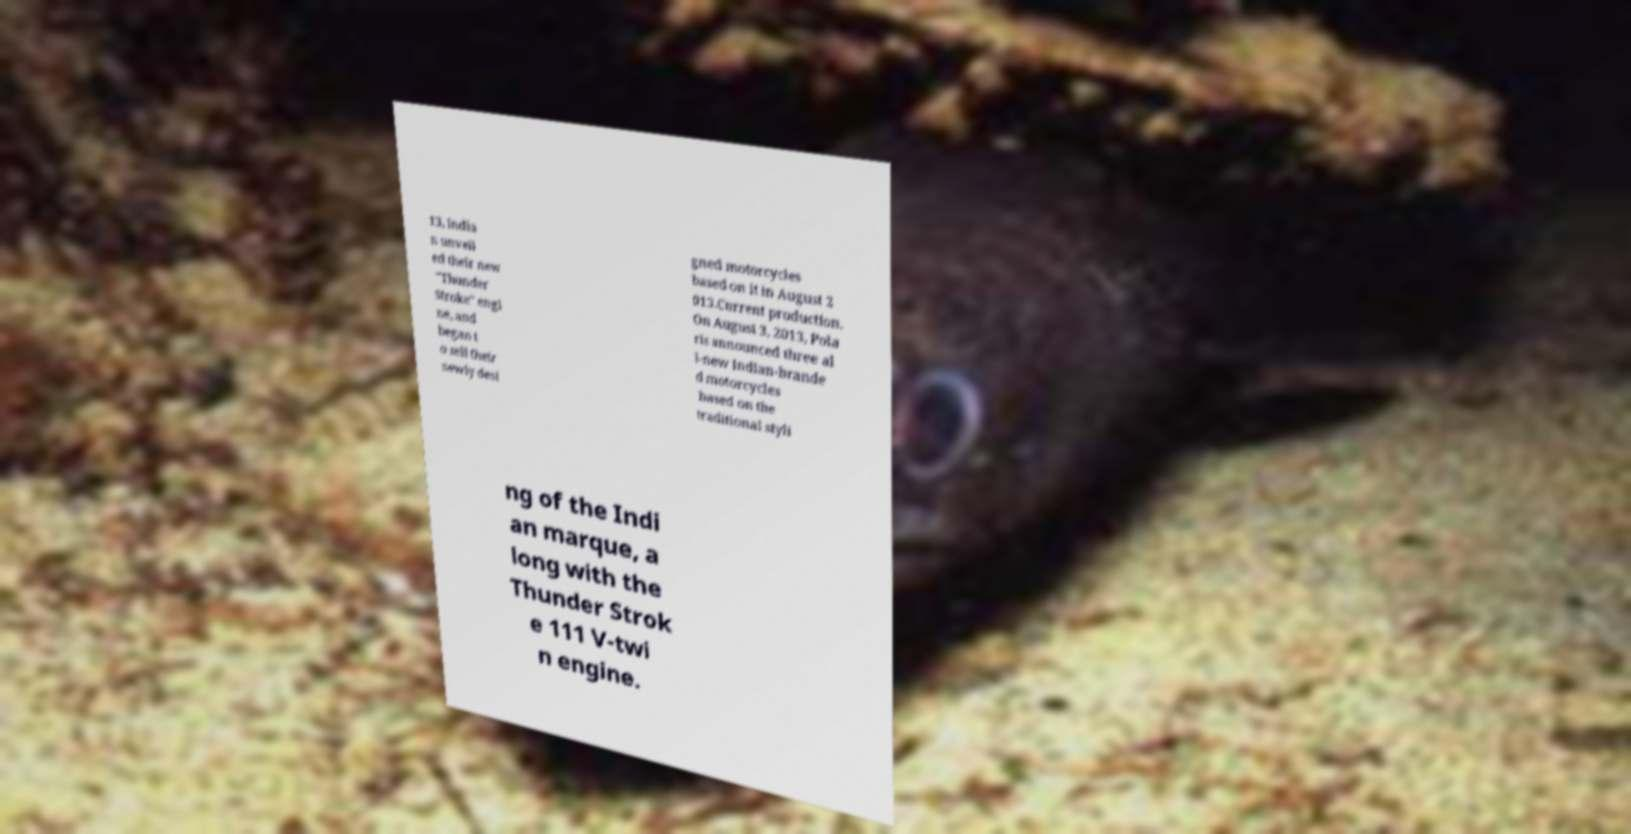Can you accurately transcribe the text from the provided image for me? 13, India n unveil ed their new "Thunder Stroke" engi ne, and began t o sell their newly desi gned motorcycles based on it in August 2 013.Current production. On August 3, 2013, Pola ris announced three al l-new Indian-brande d motorcycles based on the traditional styli ng of the Indi an marque, a long with the Thunder Strok e 111 V-twi n engine. 